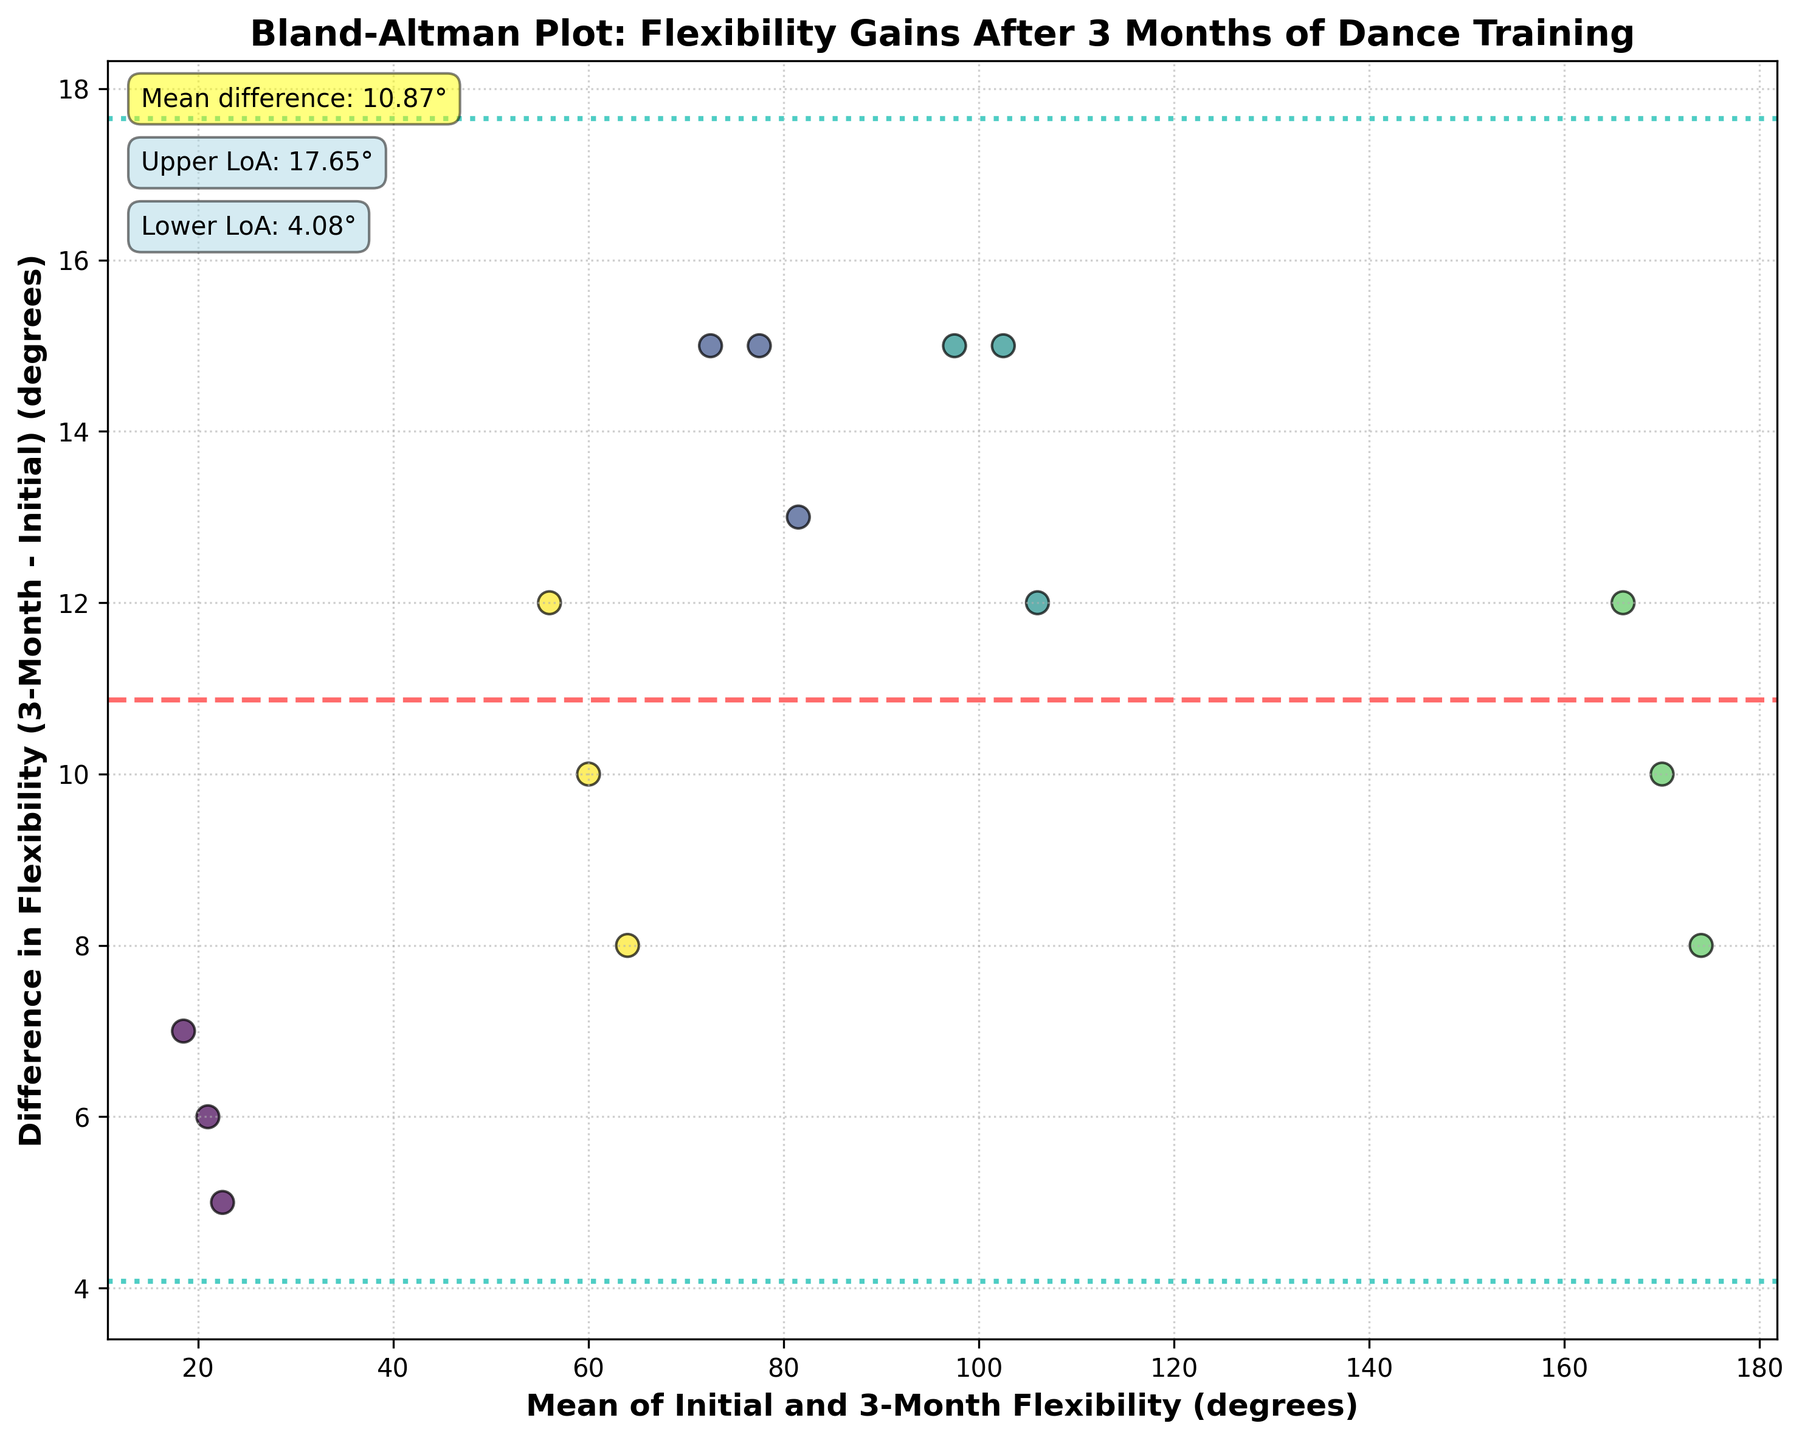What is the title of the figure? The title of the figure is displayed at the top of the plot. It reads "Bland-Altman Plot: Flexibility Gains After 3 Months of Dance Training".
Answer: Bland-Altman Plot: Flexibility Gains After 3 Months of Dance Training What is represented by the y-axis label? The y-axis label describes what is being measured along the y-axis. It reads "Difference in Flexibility (3-Month - Initial) (degrees)", indicating it shows the difference between flexibility after 3 months and initial flexibility in degrees.
Answer: Difference in Flexibility (3-Month - Initial) (degrees) Which body part showed the largest positive flexibility gain? The scatter points indicate the difference in flexibility gains for different body parts. The largest positive gain is the highest point on the y-axis. According to the legend, the body parts are color-coded. You would identify the highest point and its corresponding color to find the body part.
Answer: Hamstring Stretch What are the mean difference and the limits of agreement? The plot has horizontal lines and annotations indicating the mean difference and limits of agreement. The mean difference is given as a dashed line, while the limits of agreement are dotted lines, both with their respective annotations.
Answer: Mean difference: 11.13°, Upper LoA: 16.18°, Lower LoA: 6.08° How does the mean difference compare to the limits of agreement? The mean difference is the central dashed line, and the limits of agreement are the two dotted lines above and below it. The mean difference lies between the upper and lower limits of agreement.
Answer: Mean difference lies between the limits Which body part shows the smallest flexibility gain after 3 months? To determine the smallest flexibility gain, find the lowest point on the y-axis representing the difference in flexibility. Referring to the color legend and examining the scatter points, it is identified by its color.
Answer: Shoulder Abduction What is the range of the mean flexibility gains? The mean flexibility is plotted on the x-axis. To find the range, check the minimum and maximum values on the x-axis where data points are plotted.
Answer: Approximately 55° to 175° Which body part has the most varied flexibility gains among the dancers? This question involves comparing the spread of differences for each color-coded body part. Look for the body part with the widest vertical spread of points.
Answer: Looks like Hip Flexion Is the flexibility gain more consistent for any specific body part? Consistency is indicated by how closely the points for each body part are clustered around the mean difference. Identify the body part with the least vertical spread of points.
Answer: Ankle Dorsiflexion Are there any outliers in the flexibility gains? Outliers can be identified as points that fall far from the mean difference and the limits of agreement lines. Spot any data points significantly distant from the other points.
Answer: No significant outliers visible 